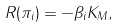<formula> <loc_0><loc_0><loc_500><loc_500>R ( \pi _ { i } ) = - \beta _ { i } K _ { M } ,</formula> 